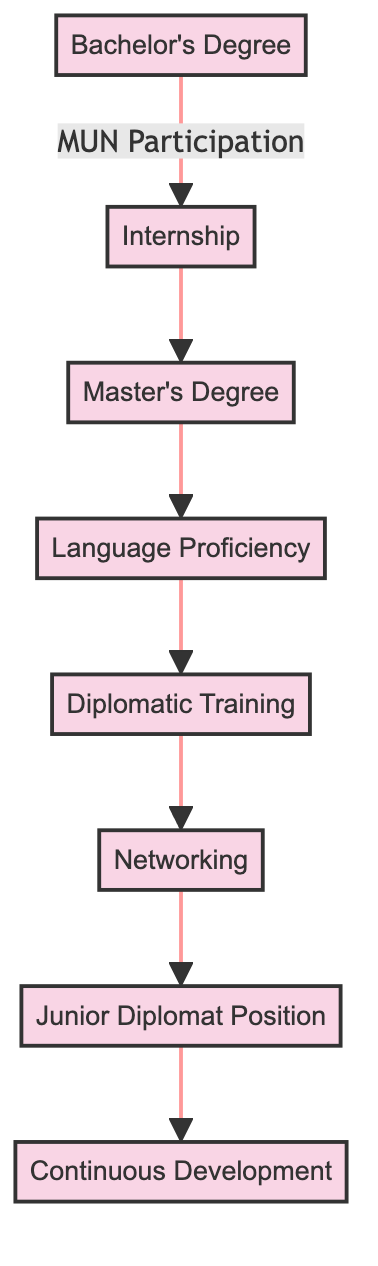What is the first milestone in the pathway? The first milestone represented in the diagram is labeled "Bachelor's Degree in International Relations or Related Field." It is positioned at the top and connected with a downward flow to the next node.
Answer: Bachelor's Degree in International Relations or Related Field How many total milestones are presented in the diagram? The diagram includes a total of eight milestones that represent distinct steps in the pathway to becoming a diplomat, each marked by its own node.
Answer: 8 Which milestone follows after "Participation in Model United Nations"? According to the diagram, "Internship at Ministry of Foreign Affairs of Suriname" directly follows "Participation in Model United Nations," showing the sequential step in the pathway.
Answer: Internship at Ministry of Foreign Affairs of Suriname What are the last two milestones in the pathway? The last two milestones, based on the flow of the diagram, are "Junior Diplomat Position" followed by "Continuous Professional Development," indicating the progression into professional roles and continual learning.
Answer: Junior Diplomat Position, Continuous Professional Development What is the relationship between "Foreign Language Proficiency" and "Diplomatic Training Programs"? In the diagram, "Foreign Language Proficiency" comes directly before "Diplomatic Training Programs," indicating that achieving language skills is a prerequisite to engaging in diplomatic training.
Answer: Foreign Language Proficiency is before Diplomatic Training Programs 